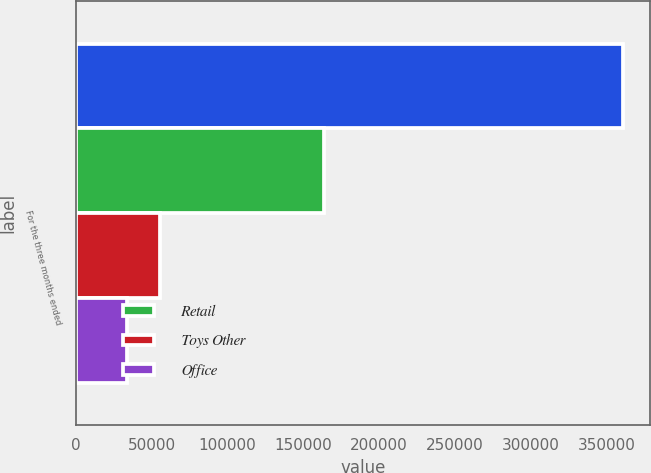Convert chart. <chart><loc_0><loc_0><loc_500><loc_500><stacked_bar_chart><ecel><fcel>For the three months ended<nl><fcel>nan<fcel>360488<nl><fcel>Retail<fcel>163857<nl><fcel>Toys Other<fcel>55394<nl><fcel>Office<fcel>33845<nl></chart> 